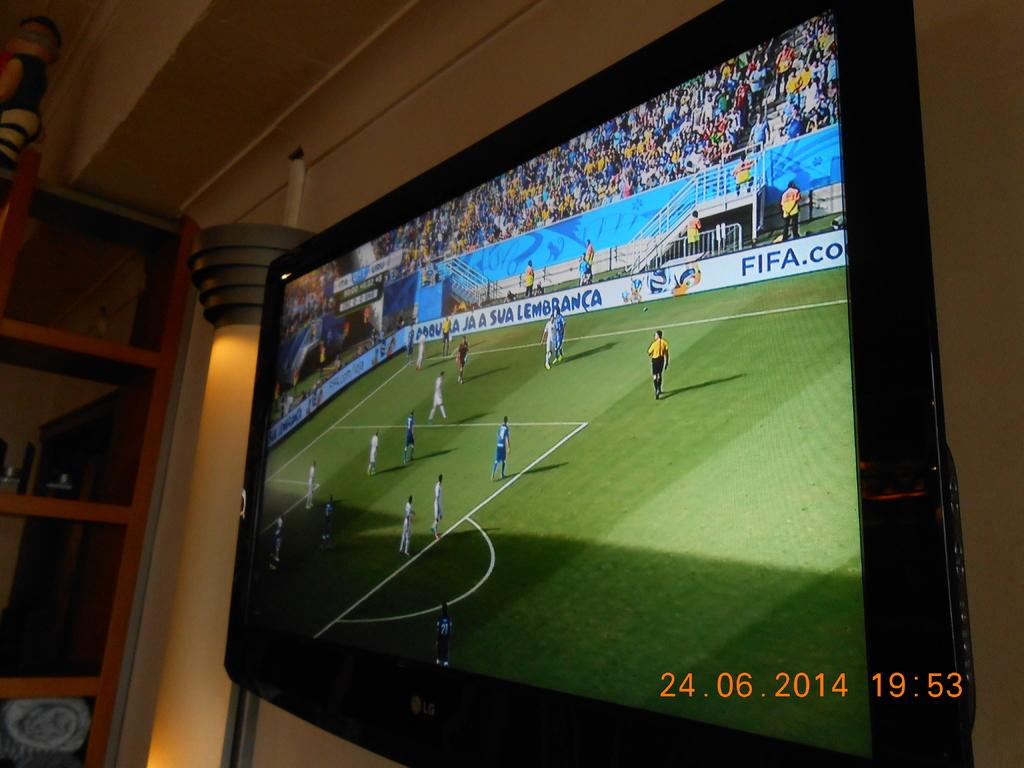<image>
Summarize the visual content of the image. A soccer game is on TV, with the stadium bearing advertisements for FIFA. 